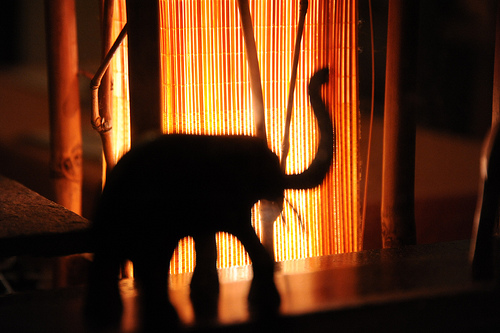<image>
Is there a elephant in front of the bamboo? Yes. The elephant is positioned in front of the bamboo, appearing closer to the camera viewpoint. 